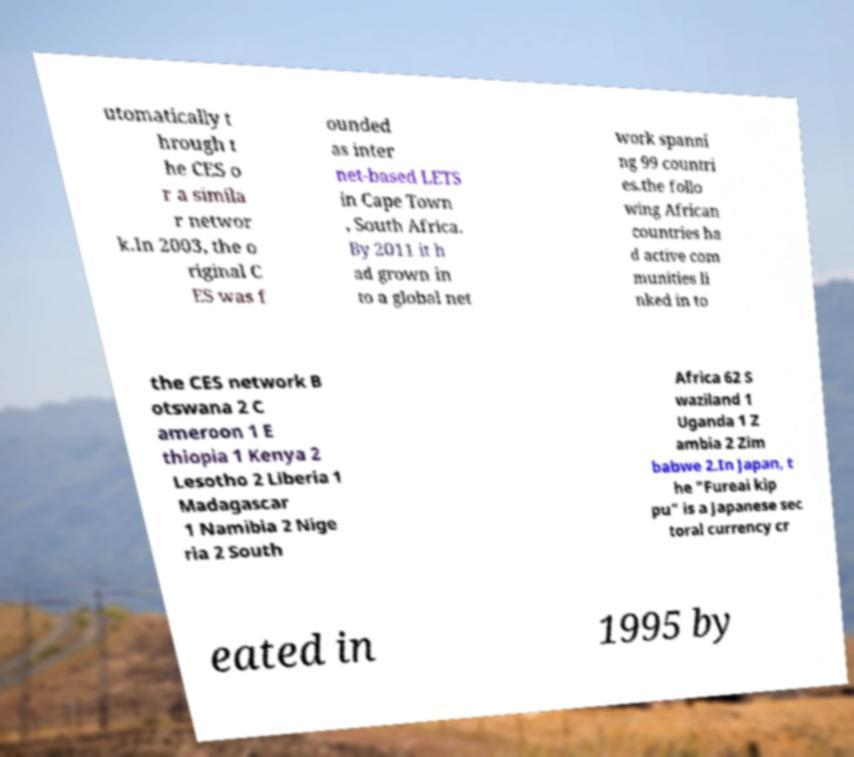Can you read and provide the text displayed in the image?This photo seems to have some interesting text. Can you extract and type it out for me? utomatically t hrough t he CES o r a simila r networ k.In 2003, the o riginal C ES was f ounded as inter net-based LETS in Cape Town , South Africa. By 2011 it h ad grown in to a global net work spanni ng 99 countri es.the follo wing African countries ha d active com munities li nked in to the CES network B otswana 2 C ameroon 1 E thiopia 1 Kenya 2 Lesotho 2 Liberia 1 Madagascar 1 Namibia 2 Nige ria 2 South Africa 62 S waziland 1 Uganda 1 Z ambia 2 Zim babwe 2.In Japan, t he "Fureai kip pu" is a Japanese sec toral currency cr eated in 1995 by 